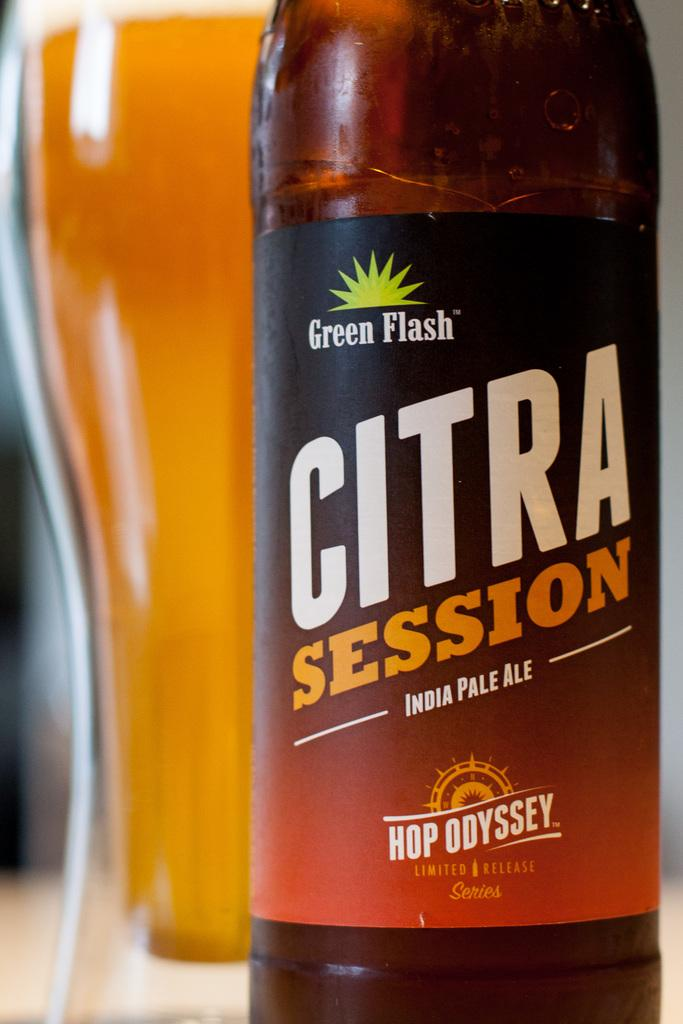Provide a one-sentence caption for the provided image. Large Citra Session beer bottle next to a cup of beer. 